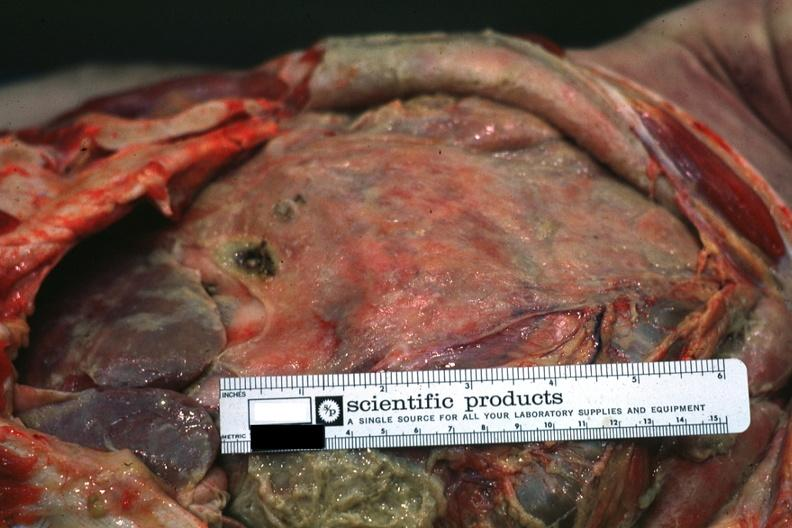s metastatic carcinoma prostate present?
Answer the question using a single word or phrase. No 